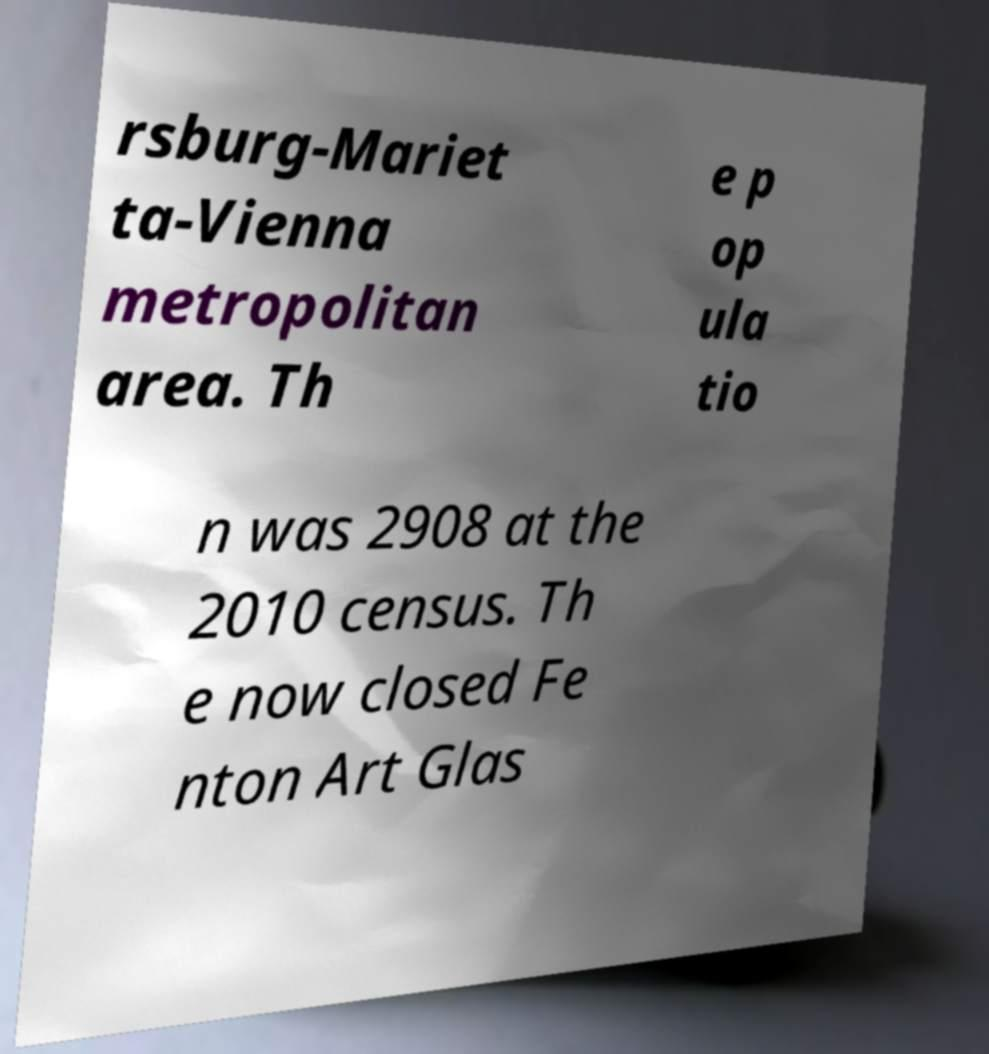What messages or text are displayed in this image? I need them in a readable, typed format. rsburg-Mariet ta-Vienna metropolitan area. Th e p op ula tio n was 2908 at the 2010 census. Th e now closed Fe nton Art Glas 